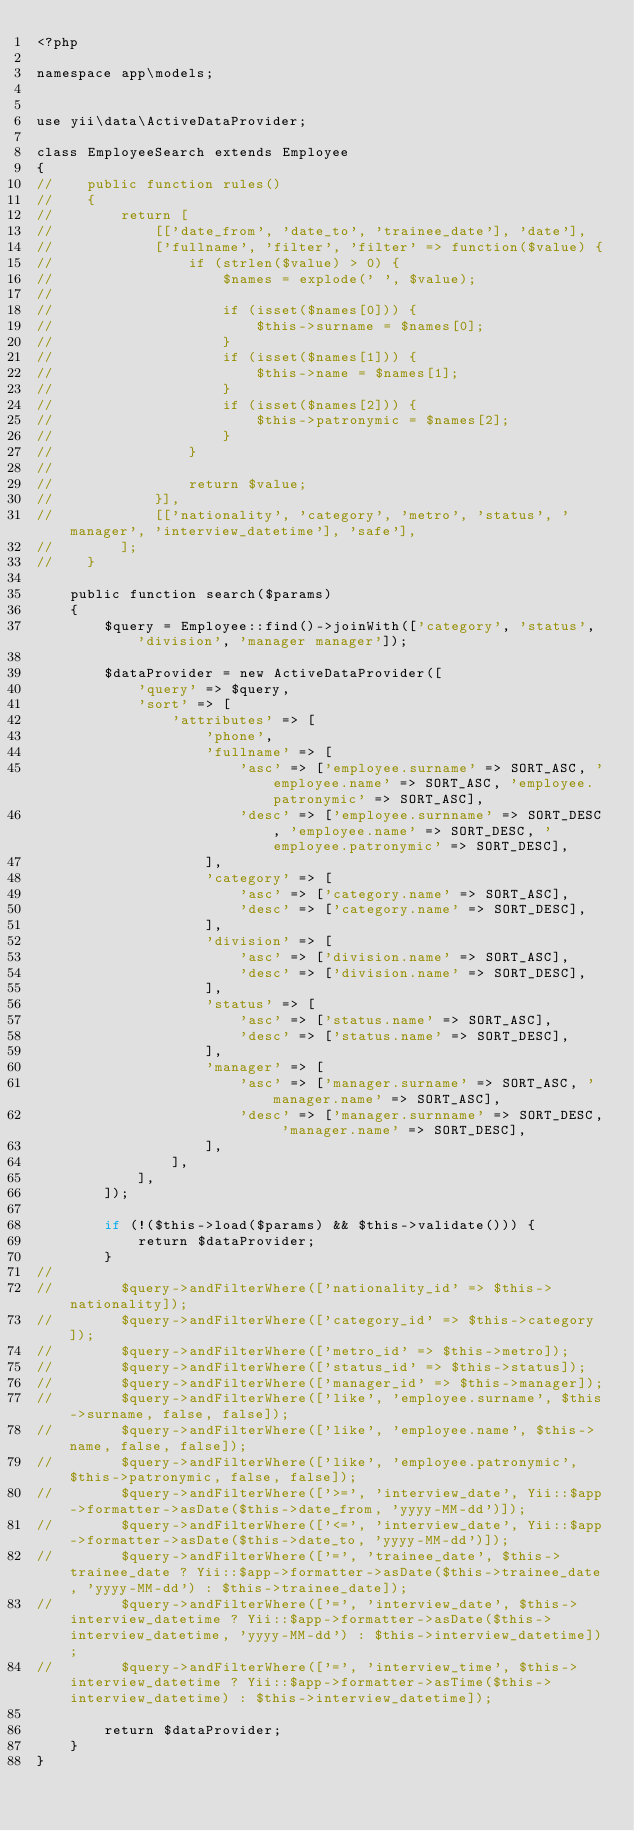<code> <loc_0><loc_0><loc_500><loc_500><_PHP_><?php

namespace app\models;


use yii\data\ActiveDataProvider;

class EmployeeSearch extends Employee
{
//    public function rules()
//    {
//        return [
//            [['date_from', 'date_to', 'trainee_date'], 'date'],
//            ['fullname', 'filter', 'filter' => function($value) {
//                if (strlen($value) > 0) {
//                    $names = explode(' ', $value);
//
//                    if (isset($names[0])) {
//                        $this->surname = $names[0];
//                    }
//                    if (isset($names[1])) {
//                        $this->name = $names[1];
//                    }
//                    if (isset($names[2])) {
//                        $this->patronymic = $names[2];
//                    }
//                }
//
//                return $value;
//            }],
//            [['nationality', 'category', 'metro', 'status', 'manager', 'interview_datetime'], 'safe'],
//        ];
//    }

    public function search($params)
    {
        $query = Employee::find()->joinWith(['category', 'status', 'division', 'manager manager']);

        $dataProvider = new ActiveDataProvider([
            'query' => $query,
            'sort' => [
                'attributes' => [
                    'phone',
                    'fullname' => [
                        'asc' => ['employee.surname' => SORT_ASC, 'employee.name' => SORT_ASC, 'employee.patronymic' => SORT_ASC],
                        'desc' => ['employee.surnname' => SORT_DESC, 'employee.name' => SORT_DESC, 'employee.patronymic' => SORT_DESC],
                    ],
                    'category' => [
                        'asc' => ['category.name' => SORT_ASC],
                        'desc' => ['category.name' => SORT_DESC],
                    ],
                    'division' => [
                        'asc' => ['division.name' => SORT_ASC],
                        'desc' => ['division.name' => SORT_DESC],
                    ],
                    'status' => [
                        'asc' => ['status.name' => SORT_ASC],
                        'desc' => ['status.name' => SORT_DESC],
                    ],
                    'manager' => [
                        'asc' => ['manager.surname' => SORT_ASC, 'manager.name' => SORT_ASC],
                        'desc' => ['manager.surnname' => SORT_DESC, 'manager.name' => SORT_DESC],
                    ],
                ],
            ],
        ]);

        if (!($this->load($params) && $this->validate())) {
            return $dataProvider;
        }
//
//        $query->andFilterWhere(['nationality_id' => $this->nationality]);
//        $query->andFilterWhere(['category_id' => $this->category]);
//        $query->andFilterWhere(['metro_id' => $this->metro]);
//        $query->andFilterWhere(['status_id' => $this->status]);
//        $query->andFilterWhere(['manager_id' => $this->manager]);
//        $query->andFilterWhere(['like', 'employee.surname', $this->surname, false, false]);
//        $query->andFilterWhere(['like', 'employee.name', $this->name, false, false]);
//        $query->andFilterWhere(['like', 'employee.patronymic', $this->patronymic, false, false]);
//        $query->andFilterWhere(['>=', 'interview_date', Yii::$app->formatter->asDate($this->date_from, 'yyyy-MM-dd')]);
//        $query->andFilterWhere(['<=', 'interview_date', Yii::$app->formatter->asDate($this->date_to, 'yyyy-MM-dd')]);
//        $query->andFilterWhere(['=', 'trainee_date', $this->trainee_date ? Yii::$app->formatter->asDate($this->trainee_date, 'yyyy-MM-dd') : $this->trainee_date]);
//        $query->andFilterWhere(['=', 'interview_date', $this->interview_datetime ? Yii::$app->formatter->asDate($this->interview_datetime, 'yyyy-MM-dd') : $this->interview_datetime]);
//        $query->andFilterWhere(['=', 'interview_time', $this->interview_datetime ? Yii::$app->formatter->asTime($this->interview_datetime) : $this->interview_datetime]);

        return $dataProvider;
    }
}</code> 